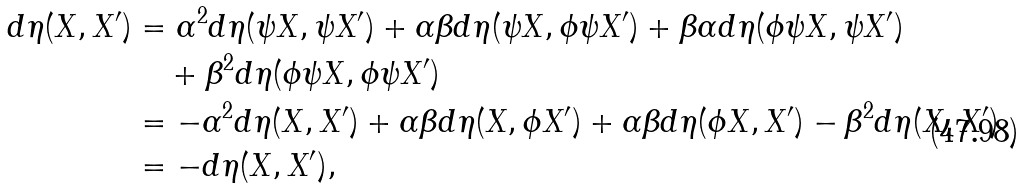<formula> <loc_0><loc_0><loc_500><loc_500>d \eta ( X , X ^ { \prime } ) & = \alpha ^ { 2 } d \eta ( \psi X , \psi X ^ { \prime } ) + \alpha \beta d \eta ( \psi X , \phi \psi X ^ { \prime } ) + \beta \alpha d \eta ( \phi \psi X , \psi X ^ { \prime } ) \\ & \quad + \beta ^ { 2 } d \eta ( \phi \psi X , \phi \psi X ^ { \prime } ) \\ & = - \alpha ^ { 2 } d \eta ( X , X ^ { \prime } ) + \alpha \beta d \eta ( X , \phi X ^ { \prime } ) + \alpha \beta d \eta ( \phi X , X ^ { \prime } ) - \beta ^ { 2 } d \eta ( X , X ^ { \prime } ) \\ & = - d \eta ( X , X ^ { \prime } ) ,</formula> 